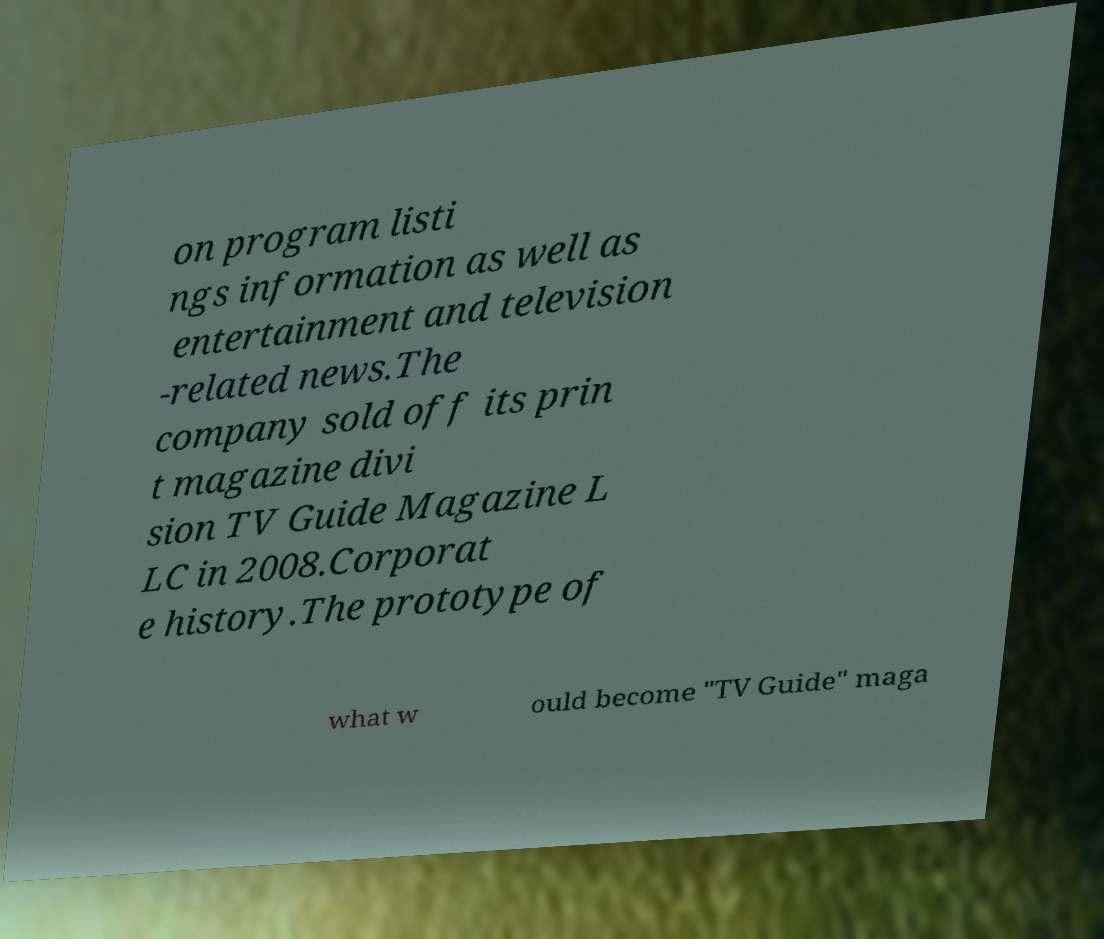What messages or text are displayed in this image? I need them in a readable, typed format. on program listi ngs information as well as entertainment and television -related news.The company sold off its prin t magazine divi sion TV Guide Magazine L LC in 2008.Corporat e history.The prototype of what w ould become "TV Guide" maga 